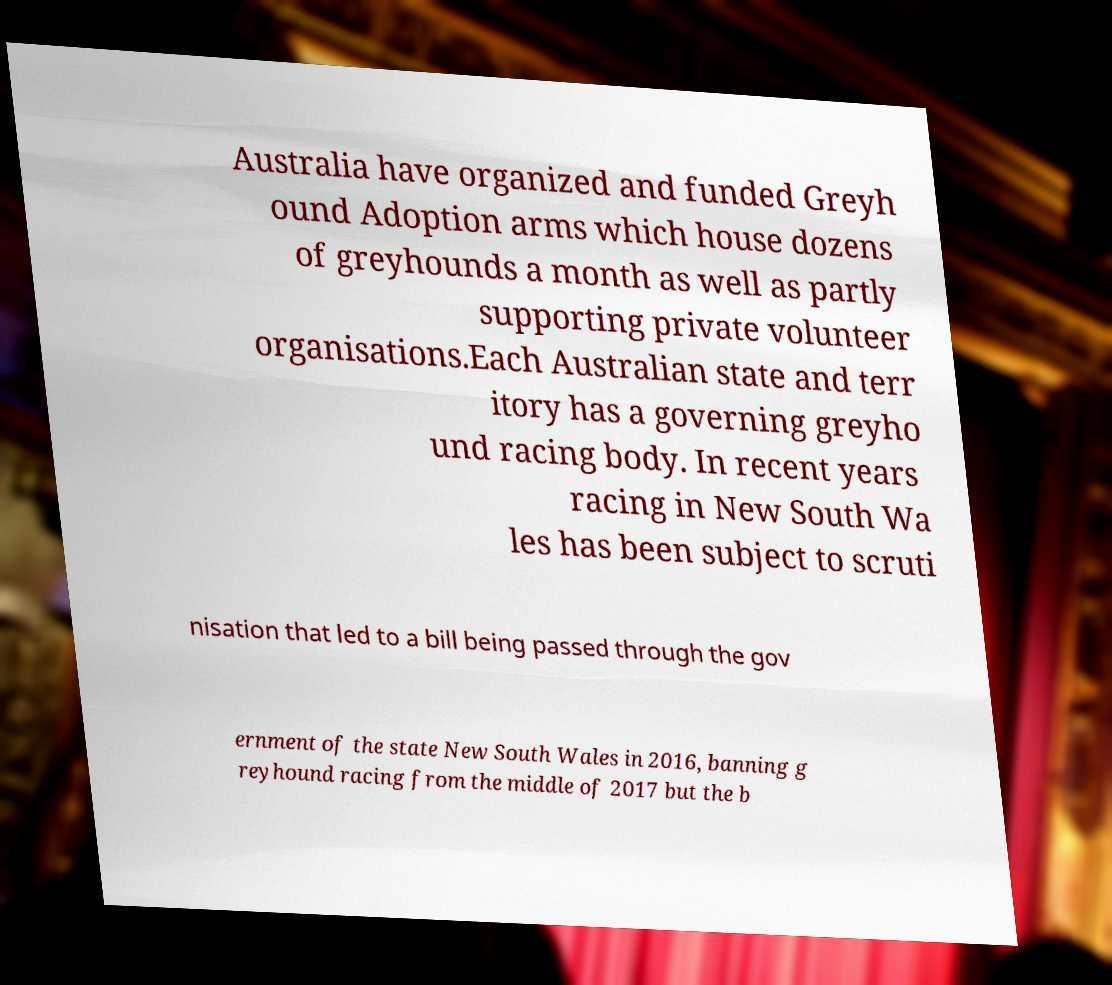What messages or text are displayed in this image? I need them in a readable, typed format. Australia have organized and funded Greyh ound Adoption arms which house dozens of greyhounds a month as well as partly supporting private volunteer organisations.Each Australian state and terr itory has a governing greyho und racing body. In recent years racing in New South Wa les has been subject to scruti nisation that led to a bill being passed through the gov ernment of the state New South Wales in 2016, banning g reyhound racing from the middle of 2017 but the b 